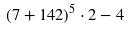<formula> <loc_0><loc_0><loc_500><loc_500>( 7 + 1 4 2 ) ^ { 5 } \cdot 2 - 4</formula> 